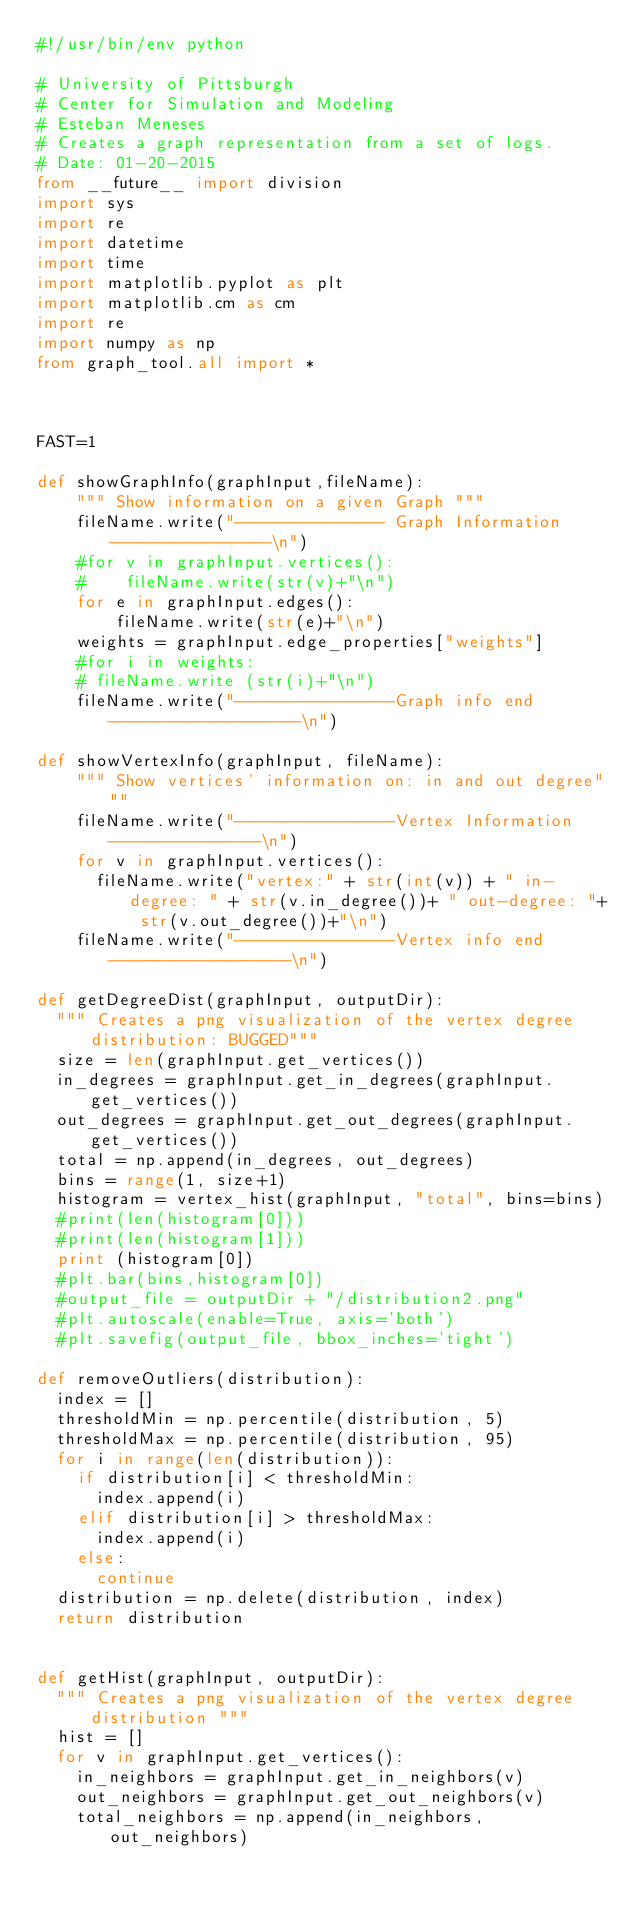Convert code to text. <code><loc_0><loc_0><loc_500><loc_500><_Python_>#!/usr/bin/env python

# University of Pittsburgh
# Center for Simulation and Modeling
# Esteban Meneses
# Creates a graph representation from a set of logs.
# Date: 01-20-2015
from __future__ import division
import sys
import re
import datetime
import time
import matplotlib.pyplot as plt
import matplotlib.cm as cm
import re
import numpy as np
from graph_tool.all import *



FAST=1

def showGraphInfo(graphInput,fileName):
    """ Show information on a given Graph """
    fileName.write("--------------- Graph Information----------------\n")
    #for v in graphInput.vertices():
    #    fileName.write(str(v)+"\n")
    for e in graphInput.edges():
        fileName.write(str(e)+"\n")
    weights = graphInput.edge_properties["weights"]
    #for i in weights:
    #	fileName.write (str(i)+"\n") 
    fileName.write("----------------Graph info end -------------------\n")

def showVertexInfo(graphInput, fileName):
    """ Show vertices' information on: in and out degree"""
    fileName.write("----------------Vertex Information ---------------\n")
    for v in graphInput.vertices():
    	fileName.write("vertex:" + str(int(v)) + " in-degree: " + str(v.in_degree())+ " out-degree: "+ str(v.out_degree())+"\n")
    fileName.write("----------------Vertex info end ------------------\n")

def getDegreeDist(graphInput, outputDir):
	""" Creates a png visualization of the vertex degree distribution: BUGGED"""
	size = len(graphInput.get_vertices())
	in_degrees = graphInput.get_in_degrees(graphInput.get_vertices())	
	out_degrees = graphInput.get_out_degrees(graphInput.get_vertices())
	total = np.append(in_degrees, out_degrees)
	bins = range(1, size+1)
	histogram = vertex_hist(graphInput, "total", bins=bins)
	#print(len(histogram[0]))
	#print(len(histogram[1]))
	print (histogram[0])	
	#plt.bar(bins,histogram[0])
	#output_file = outputDir + "/distribution2.png"
	#plt.autoscale(enable=True, axis='both')
	#plt.savefig(output_file, bbox_inches='tight')

def removeOutliers(distribution):
	index = []
	thresholdMin = np.percentile(distribution, 5)
	thresholdMax = np.percentile(distribution, 95)
	for i in range(len(distribution)):
		if distribution[i] < thresholdMin:
			index.append(i)
		elif distribution[i] > thresholdMax:
			index.append(i)
		else:
			continue
	distribution = np.delete(distribution, index)
	return distribution


def getHist(graphInput, outputDir):
	""" Creates a png visualization of the vertex degree distribution """
	hist = []
	for v in graphInput.get_vertices():
		in_neighbors = graphInput.get_in_neighbors(v)
		out_neighbors = graphInput.get_out_neighbors(v)
		total_neighbors = np.append(in_neighbors, out_neighbors)</code> 